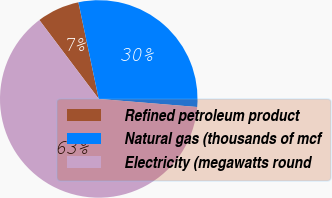<chart> <loc_0><loc_0><loc_500><loc_500><pie_chart><fcel>Refined petroleum product<fcel>Natural gas (thousands of mcf<fcel>Electricity (megawatts round<nl><fcel>6.97%<fcel>29.61%<fcel>63.43%<nl></chart> 